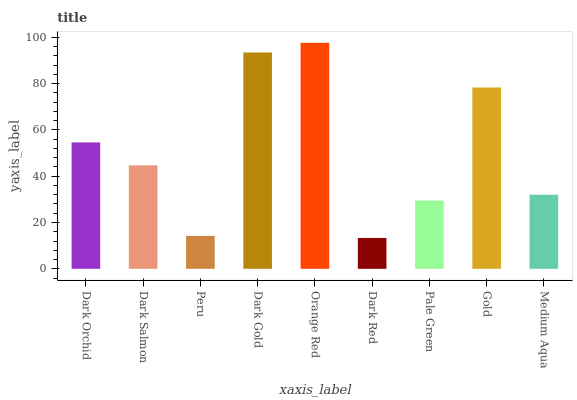Is Dark Red the minimum?
Answer yes or no. Yes. Is Orange Red the maximum?
Answer yes or no. Yes. Is Dark Salmon the minimum?
Answer yes or no. No. Is Dark Salmon the maximum?
Answer yes or no. No. Is Dark Orchid greater than Dark Salmon?
Answer yes or no. Yes. Is Dark Salmon less than Dark Orchid?
Answer yes or no. Yes. Is Dark Salmon greater than Dark Orchid?
Answer yes or no. No. Is Dark Orchid less than Dark Salmon?
Answer yes or no. No. Is Dark Salmon the high median?
Answer yes or no. Yes. Is Dark Salmon the low median?
Answer yes or no. Yes. Is Gold the high median?
Answer yes or no. No. Is Pale Green the low median?
Answer yes or no. No. 